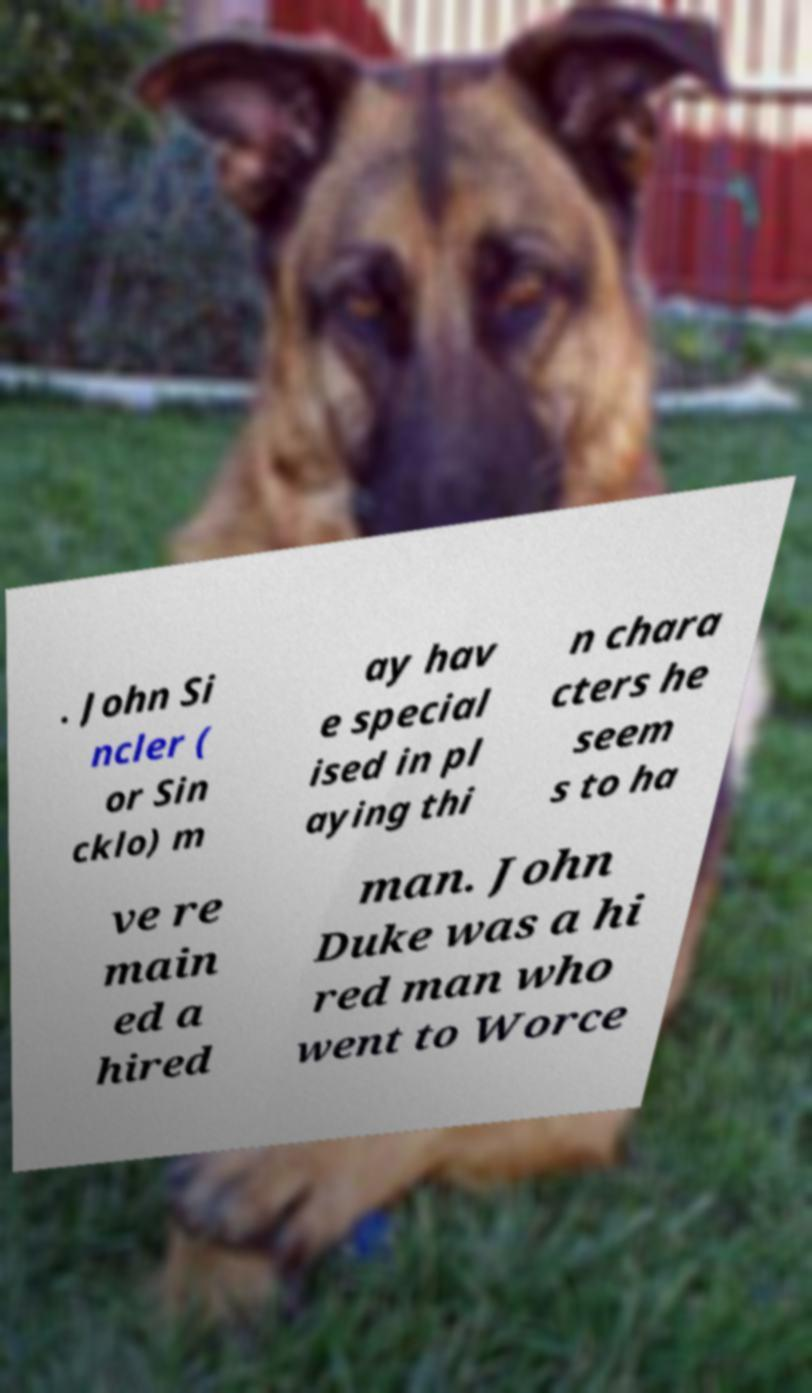There's text embedded in this image that I need extracted. Can you transcribe it verbatim? . John Si ncler ( or Sin cklo) m ay hav e special ised in pl aying thi n chara cters he seem s to ha ve re main ed a hired man. John Duke was a hi red man who went to Worce 